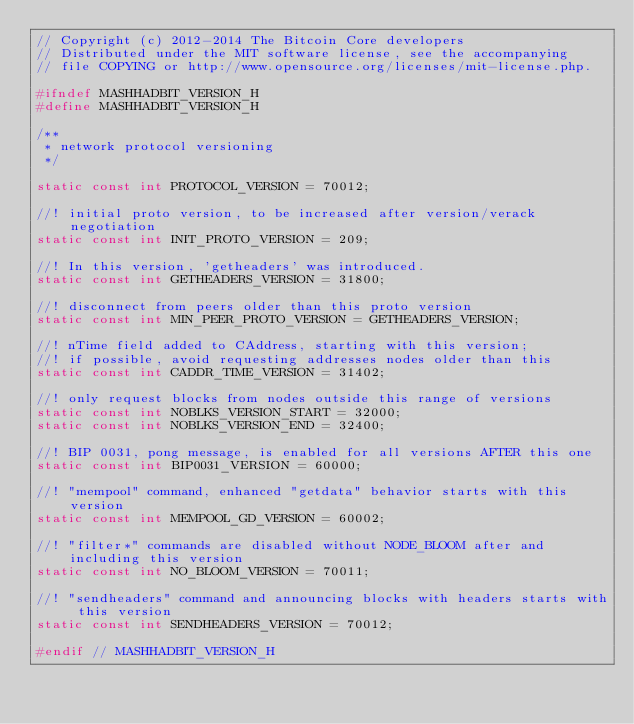<code> <loc_0><loc_0><loc_500><loc_500><_C_>// Copyright (c) 2012-2014 The Bitcoin Core developers
// Distributed under the MIT software license, see the accompanying
// file COPYING or http://www.opensource.org/licenses/mit-license.php.

#ifndef MASHHADBIT_VERSION_H
#define MASHHADBIT_VERSION_H

/**
 * network protocol versioning
 */

static const int PROTOCOL_VERSION = 70012;

//! initial proto version, to be increased after version/verack negotiation
static const int INIT_PROTO_VERSION = 209;

//! In this version, 'getheaders' was introduced.
static const int GETHEADERS_VERSION = 31800;

//! disconnect from peers older than this proto version
static const int MIN_PEER_PROTO_VERSION = GETHEADERS_VERSION;

//! nTime field added to CAddress, starting with this version;
//! if possible, avoid requesting addresses nodes older than this
static const int CADDR_TIME_VERSION = 31402;

//! only request blocks from nodes outside this range of versions
static const int NOBLKS_VERSION_START = 32000;
static const int NOBLKS_VERSION_END = 32400;

//! BIP 0031, pong message, is enabled for all versions AFTER this one
static const int BIP0031_VERSION = 60000;

//! "mempool" command, enhanced "getdata" behavior starts with this version
static const int MEMPOOL_GD_VERSION = 60002;

//! "filter*" commands are disabled without NODE_BLOOM after and including this version
static const int NO_BLOOM_VERSION = 70011;

//! "sendheaders" command and announcing blocks with headers starts with this version
static const int SENDHEADERS_VERSION = 70012;

#endif // MASHHADBIT_VERSION_H
</code> 